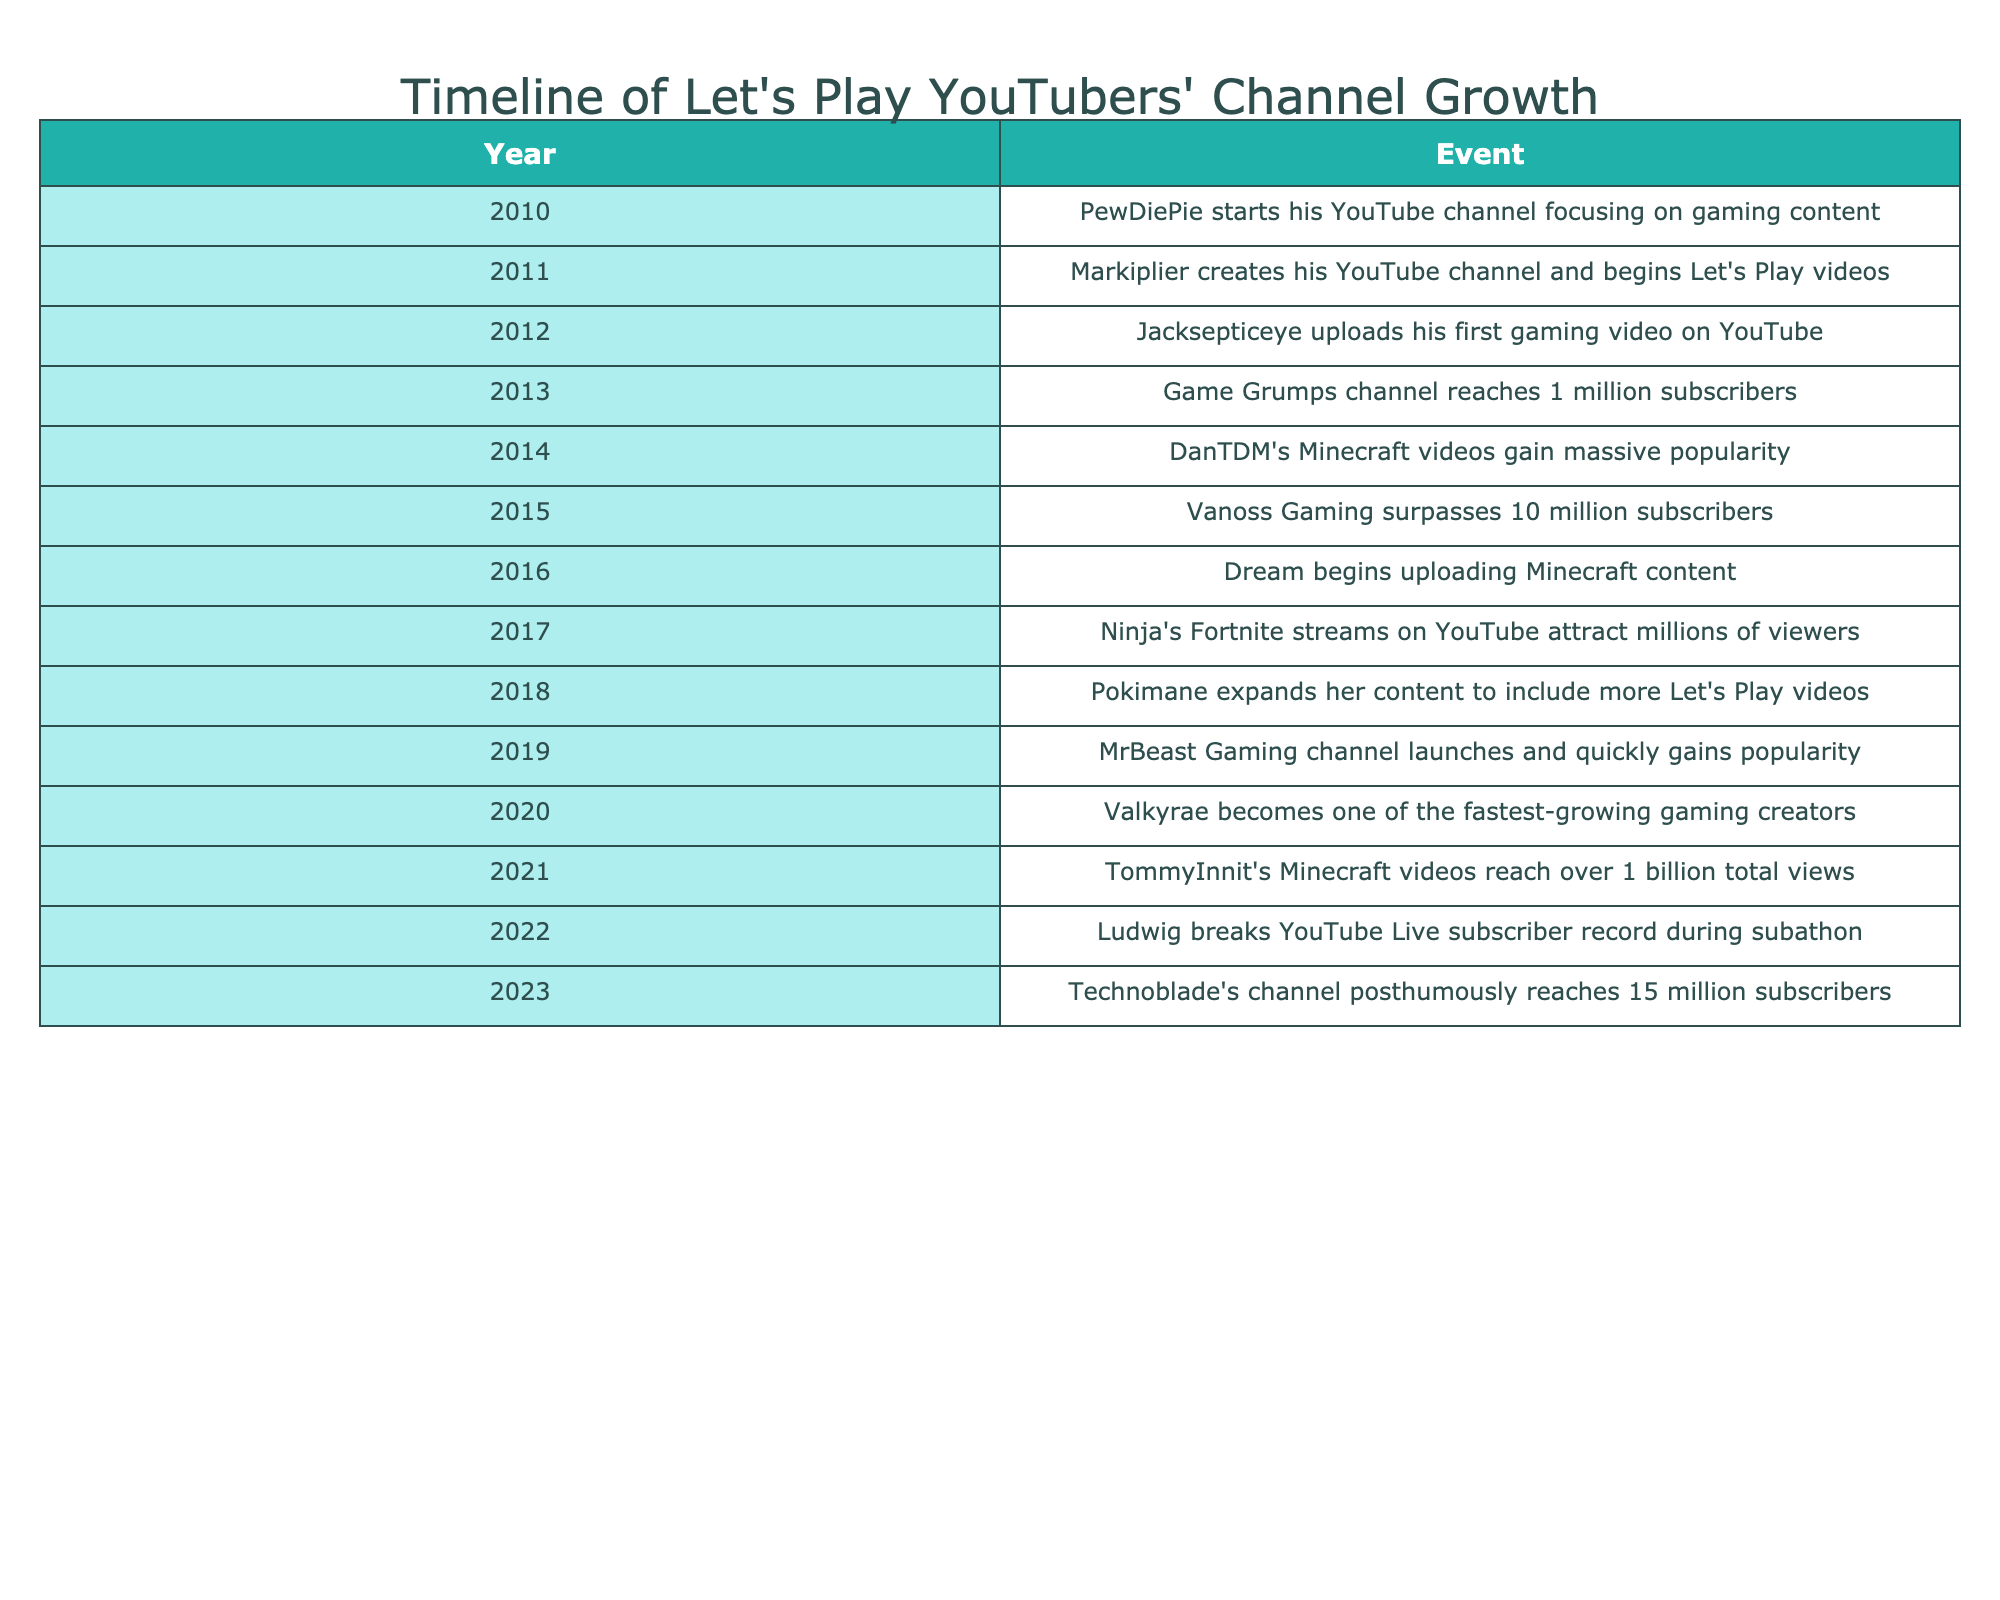What year did PewDiePie start his YouTube channel? According to the table, PewDiePie started his YouTube channel in 2010. This information is directly stated in the first row of the table.
Answer: 2010 Which YouTuber's Minecraft videos gained massive popularity in 2014? The table shows that in 2014, DanTDM's Minecraft videos gained massive popularity. This is clearly indicated in the row corresponding to the year 2014.
Answer: DanTDM When did TommyInnit's Minecraft videos reach over 1 billion total views? The table states that TommyInnit's Minecraft videos reached over 1 billion total views in 2021, which can be found in the row for that year.
Answer: 2021 How many years passed from Jacksepticeye's first upload to the launch of MrBeast Gaming? Jacksepticeye uploaded his first gaming video in 2012, and MrBeast Gaming launched in 2019. The difference is 2019 - 2012 = 7 years. Therefore, 7 years passed between these two events.
Answer: 7 Did Ninja start uploading content on YouTube before or after DanTDM? The table indicates that DanTDM gained popularity in 2014, while Ninja's Fortnite streams attracted viewers in 2017. Therefore, Ninja began uploading content after DanTDM. This can be confirmed by the years displayed in the respective rows.
Answer: After What was the growth pattern in YouTube subscribers for Vanoss Gaming compared to Game Grumps from 2013 to 2015? The table states that Game Grumps reached 1 million subscribers in 2013, and by 2015, Vanoss Gaming surpassed 10 million subscribers. This shows that while Game Grumps had notable growth, Vanoss Gaming had a much larger growth trajectory in terms of subscriber count. In summary, Vanoss Gaming's growth was significantly greater than that of Game Grumps during this time.
Answer: Vanoss Gaming had greater growth 